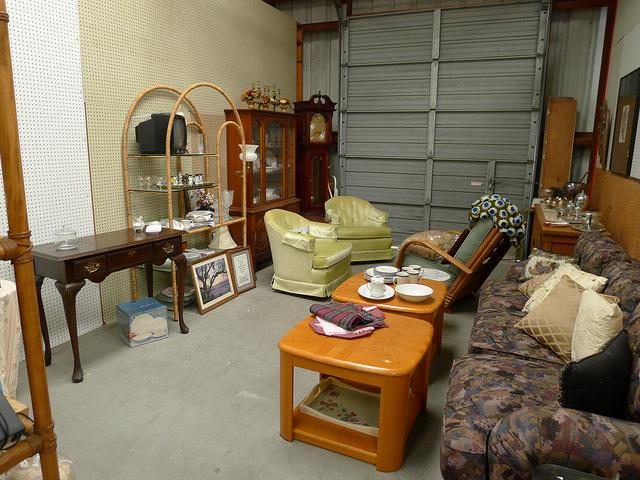Based on the door this furniture is most likely located in what? storage unit 